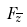Convert formula to latex. <formula><loc_0><loc_0><loc_500><loc_500>F _ { \overline { z } }</formula> 